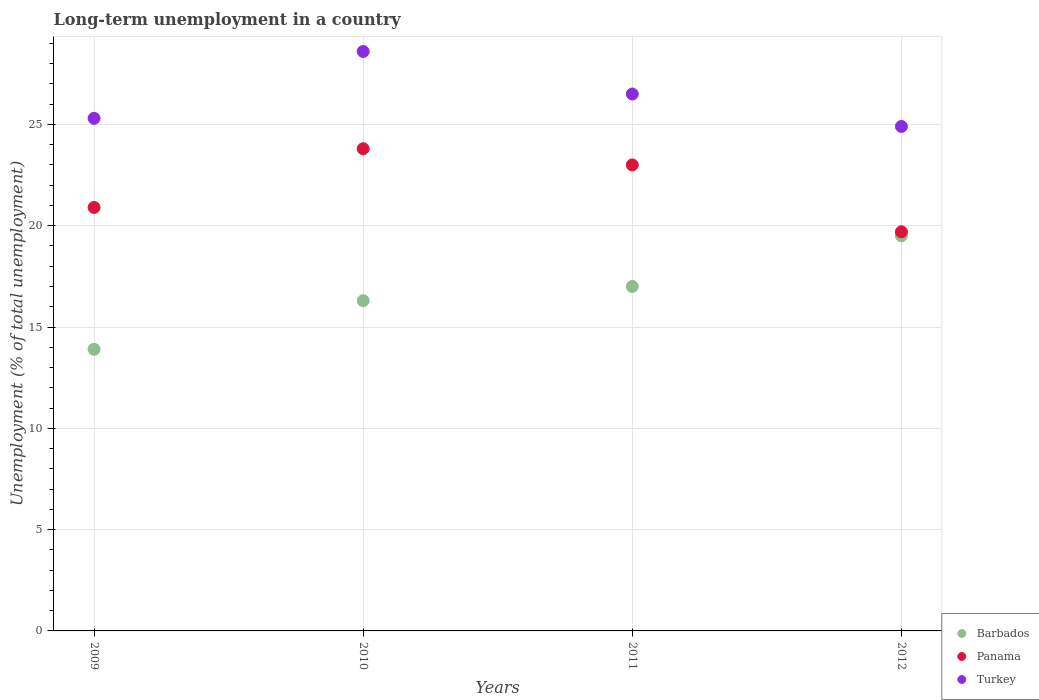Is the number of dotlines equal to the number of legend labels?
Give a very brief answer. Yes. What is the percentage of long-term unemployed population in Barbados in 2010?
Provide a succinct answer. 16.3. Across all years, what is the minimum percentage of long-term unemployed population in Turkey?
Keep it short and to the point. 24.9. In which year was the percentage of long-term unemployed population in Barbados maximum?
Keep it short and to the point. 2012. In which year was the percentage of long-term unemployed population in Panama minimum?
Offer a very short reply. 2012. What is the total percentage of long-term unemployed population in Turkey in the graph?
Make the answer very short. 105.3. What is the difference between the percentage of long-term unemployed population in Panama in 2010 and that in 2012?
Your response must be concise. 4.1. What is the difference between the percentage of long-term unemployed population in Panama in 2010 and the percentage of long-term unemployed population in Turkey in 2012?
Your answer should be compact. -1.1. What is the average percentage of long-term unemployed population in Panama per year?
Make the answer very short. 21.85. In how many years, is the percentage of long-term unemployed population in Panama greater than 22 %?
Make the answer very short. 2. What is the ratio of the percentage of long-term unemployed population in Panama in 2009 to that in 2011?
Your answer should be compact. 0.91. Is the percentage of long-term unemployed population in Turkey in 2010 less than that in 2012?
Provide a short and direct response. No. What is the difference between the highest and the second highest percentage of long-term unemployed population in Barbados?
Offer a very short reply. 2.5. What is the difference between the highest and the lowest percentage of long-term unemployed population in Turkey?
Provide a short and direct response. 3.7. In how many years, is the percentage of long-term unemployed population in Turkey greater than the average percentage of long-term unemployed population in Turkey taken over all years?
Offer a terse response. 2. Is the sum of the percentage of long-term unemployed population in Barbados in 2010 and 2012 greater than the maximum percentage of long-term unemployed population in Panama across all years?
Ensure brevity in your answer.  Yes. Is it the case that in every year, the sum of the percentage of long-term unemployed population in Barbados and percentage of long-term unemployed population in Turkey  is greater than the percentage of long-term unemployed population in Panama?
Make the answer very short. Yes. Does the percentage of long-term unemployed population in Turkey monotonically increase over the years?
Provide a short and direct response. No. How many dotlines are there?
Offer a terse response. 3. How many years are there in the graph?
Offer a terse response. 4. What is the difference between two consecutive major ticks on the Y-axis?
Your answer should be very brief. 5. Does the graph contain any zero values?
Offer a terse response. No. Where does the legend appear in the graph?
Offer a terse response. Bottom right. How are the legend labels stacked?
Your answer should be very brief. Vertical. What is the title of the graph?
Your answer should be compact. Long-term unemployment in a country. What is the label or title of the Y-axis?
Give a very brief answer. Unemployment (% of total unemployment). What is the Unemployment (% of total unemployment) of Barbados in 2009?
Give a very brief answer. 13.9. What is the Unemployment (% of total unemployment) of Panama in 2009?
Offer a very short reply. 20.9. What is the Unemployment (% of total unemployment) of Turkey in 2009?
Offer a terse response. 25.3. What is the Unemployment (% of total unemployment) in Barbados in 2010?
Keep it short and to the point. 16.3. What is the Unemployment (% of total unemployment) of Panama in 2010?
Make the answer very short. 23.8. What is the Unemployment (% of total unemployment) of Turkey in 2010?
Offer a very short reply. 28.6. What is the Unemployment (% of total unemployment) in Panama in 2011?
Your answer should be very brief. 23. What is the Unemployment (% of total unemployment) in Barbados in 2012?
Offer a very short reply. 19.5. What is the Unemployment (% of total unemployment) in Panama in 2012?
Provide a short and direct response. 19.7. What is the Unemployment (% of total unemployment) of Turkey in 2012?
Provide a succinct answer. 24.9. Across all years, what is the maximum Unemployment (% of total unemployment) in Panama?
Keep it short and to the point. 23.8. Across all years, what is the maximum Unemployment (% of total unemployment) in Turkey?
Ensure brevity in your answer.  28.6. Across all years, what is the minimum Unemployment (% of total unemployment) of Barbados?
Make the answer very short. 13.9. Across all years, what is the minimum Unemployment (% of total unemployment) of Panama?
Provide a short and direct response. 19.7. Across all years, what is the minimum Unemployment (% of total unemployment) in Turkey?
Make the answer very short. 24.9. What is the total Unemployment (% of total unemployment) in Barbados in the graph?
Your answer should be very brief. 66.7. What is the total Unemployment (% of total unemployment) of Panama in the graph?
Provide a short and direct response. 87.4. What is the total Unemployment (% of total unemployment) of Turkey in the graph?
Offer a terse response. 105.3. What is the difference between the Unemployment (% of total unemployment) of Barbados in 2009 and that in 2010?
Make the answer very short. -2.4. What is the difference between the Unemployment (% of total unemployment) in Turkey in 2009 and that in 2010?
Give a very brief answer. -3.3. What is the difference between the Unemployment (% of total unemployment) of Barbados in 2009 and that in 2011?
Offer a terse response. -3.1. What is the difference between the Unemployment (% of total unemployment) of Turkey in 2009 and that in 2011?
Keep it short and to the point. -1.2. What is the difference between the Unemployment (% of total unemployment) in Barbados in 2009 and that in 2012?
Offer a very short reply. -5.6. What is the difference between the Unemployment (% of total unemployment) in Panama in 2009 and that in 2012?
Keep it short and to the point. 1.2. What is the difference between the Unemployment (% of total unemployment) in Panama in 2010 and that in 2011?
Your answer should be compact. 0.8. What is the difference between the Unemployment (% of total unemployment) in Turkey in 2010 and that in 2011?
Ensure brevity in your answer.  2.1. What is the difference between the Unemployment (% of total unemployment) in Panama in 2010 and that in 2012?
Provide a short and direct response. 4.1. What is the difference between the Unemployment (% of total unemployment) of Turkey in 2011 and that in 2012?
Offer a terse response. 1.6. What is the difference between the Unemployment (% of total unemployment) of Barbados in 2009 and the Unemployment (% of total unemployment) of Panama in 2010?
Provide a short and direct response. -9.9. What is the difference between the Unemployment (% of total unemployment) of Barbados in 2009 and the Unemployment (% of total unemployment) of Turkey in 2010?
Ensure brevity in your answer.  -14.7. What is the difference between the Unemployment (% of total unemployment) of Panama in 2009 and the Unemployment (% of total unemployment) of Turkey in 2010?
Your answer should be compact. -7.7. What is the difference between the Unemployment (% of total unemployment) in Barbados in 2009 and the Unemployment (% of total unemployment) in Turkey in 2011?
Provide a succinct answer. -12.6. What is the difference between the Unemployment (% of total unemployment) of Panama in 2009 and the Unemployment (% of total unemployment) of Turkey in 2011?
Your answer should be compact. -5.6. What is the difference between the Unemployment (% of total unemployment) of Barbados in 2009 and the Unemployment (% of total unemployment) of Turkey in 2012?
Offer a terse response. -11. What is the difference between the Unemployment (% of total unemployment) in Barbados in 2010 and the Unemployment (% of total unemployment) in Panama in 2011?
Ensure brevity in your answer.  -6.7. What is the difference between the Unemployment (% of total unemployment) of Barbados in 2010 and the Unemployment (% of total unemployment) of Panama in 2012?
Make the answer very short. -3.4. What is the difference between the Unemployment (% of total unemployment) in Panama in 2010 and the Unemployment (% of total unemployment) in Turkey in 2012?
Give a very brief answer. -1.1. What is the difference between the Unemployment (% of total unemployment) of Barbados in 2011 and the Unemployment (% of total unemployment) of Turkey in 2012?
Offer a terse response. -7.9. What is the difference between the Unemployment (% of total unemployment) of Panama in 2011 and the Unemployment (% of total unemployment) of Turkey in 2012?
Your answer should be compact. -1.9. What is the average Unemployment (% of total unemployment) in Barbados per year?
Ensure brevity in your answer.  16.68. What is the average Unemployment (% of total unemployment) of Panama per year?
Your answer should be very brief. 21.85. What is the average Unemployment (% of total unemployment) of Turkey per year?
Give a very brief answer. 26.32. In the year 2009, what is the difference between the Unemployment (% of total unemployment) in Barbados and Unemployment (% of total unemployment) in Panama?
Keep it short and to the point. -7. In the year 2009, what is the difference between the Unemployment (% of total unemployment) of Panama and Unemployment (% of total unemployment) of Turkey?
Your response must be concise. -4.4. In the year 2010, what is the difference between the Unemployment (% of total unemployment) of Barbados and Unemployment (% of total unemployment) of Panama?
Your answer should be compact. -7.5. In the year 2011, what is the difference between the Unemployment (% of total unemployment) in Barbados and Unemployment (% of total unemployment) in Panama?
Keep it short and to the point. -6. In the year 2011, what is the difference between the Unemployment (% of total unemployment) in Barbados and Unemployment (% of total unemployment) in Turkey?
Offer a very short reply. -9.5. In the year 2011, what is the difference between the Unemployment (% of total unemployment) in Panama and Unemployment (% of total unemployment) in Turkey?
Your answer should be very brief. -3.5. In the year 2012, what is the difference between the Unemployment (% of total unemployment) of Barbados and Unemployment (% of total unemployment) of Panama?
Offer a very short reply. -0.2. In the year 2012, what is the difference between the Unemployment (% of total unemployment) of Barbados and Unemployment (% of total unemployment) of Turkey?
Give a very brief answer. -5.4. In the year 2012, what is the difference between the Unemployment (% of total unemployment) of Panama and Unemployment (% of total unemployment) of Turkey?
Provide a short and direct response. -5.2. What is the ratio of the Unemployment (% of total unemployment) of Barbados in 2009 to that in 2010?
Provide a short and direct response. 0.85. What is the ratio of the Unemployment (% of total unemployment) in Panama in 2009 to that in 2010?
Keep it short and to the point. 0.88. What is the ratio of the Unemployment (% of total unemployment) of Turkey in 2009 to that in 2010?
Give a very brief answer. 0.88. What is the ratio of the Unemployment (% of total unemployment) of Barbados in 2009 to that in 2011?
Keep it short and to the point. 0.82. What is the ratio of the Unemployment (% of total unemployment) of Panama in 2009 to that in 2011?
Make the answer very short. 0.91. What is the ratio of the Unemployment (% of total unemployment) of Turkey in 2009 to that in 2011?
Give a very brief answer. 0.95. What is the ratio of the Unemployment (% of total unemployment) of Barbados in 2009 to that in 2012?
Keep it short and to the point. 0.71. What is the ratio of the Unemployment (% of total unemployment) of Panama in 2009 to that in 2012?
Provide a short and direct response. 1.06. What is the ratio of the Unemployment (% of total unemployment) of Turkey in 2009 to that in 2012?
Your response must be concise. 1.02. What is the ratio of the Unemployment (% of total unemployment) in Barbados in 2010 to that in 2011?
Give a very brief answer. 0.96. What is the ratio of the Unemployment (% of total unemployment) in Panama in 2010 to that in 2011?
Keep it short and to the point. 1.03. What is the ratio of the Unemployment (% of total unemployment) of Turkey in 2010 to that in 2011?
Ensure brevity in your answer.  1.08. What is the ratio of the Unemployment (% of total unemployment) in Barbados in 2010 to that in 2012?
Your response must be concise. 0.84. What is the ratio of the Unemployment (% of total unemployment) of Panama in 2010 to that in 2012?
Keep it short and to the point. 1.21. What is the ratio of the Unemployment (% of total unemployment) in Turkey in 2010 to that in 2012?
Ensure brevity in your answer.  1.15. What is the ratio of the Unemployment (% of total unemployment) of Barbados in 2011 to that in 2012?
Ensure brevity in your answer.  0.87. What is the ratio of the Unemployment (% of total unemployment) in Panama in 2011 to that in 2012?
Offer a terse response. 1.17. What is the ratio of the Unemployment (% of total unemployment) of Turkey in 2011 to that in 2012?
Provide a short and direct response. 1.06. What is the difference between the highest and the second highest Unemployment (% of total unemployment) of Turkey?
Give a very brief answer. 2.1. What is the difference between the highest and the lowest Unemployment (% of total unemployment) in Barbados?
Your answer should be compact. 5.6. What is the difference between the highest and the lowest Unemployment (% of total unemployment) in Panama?
Provide a succinct answer. 4.1. 